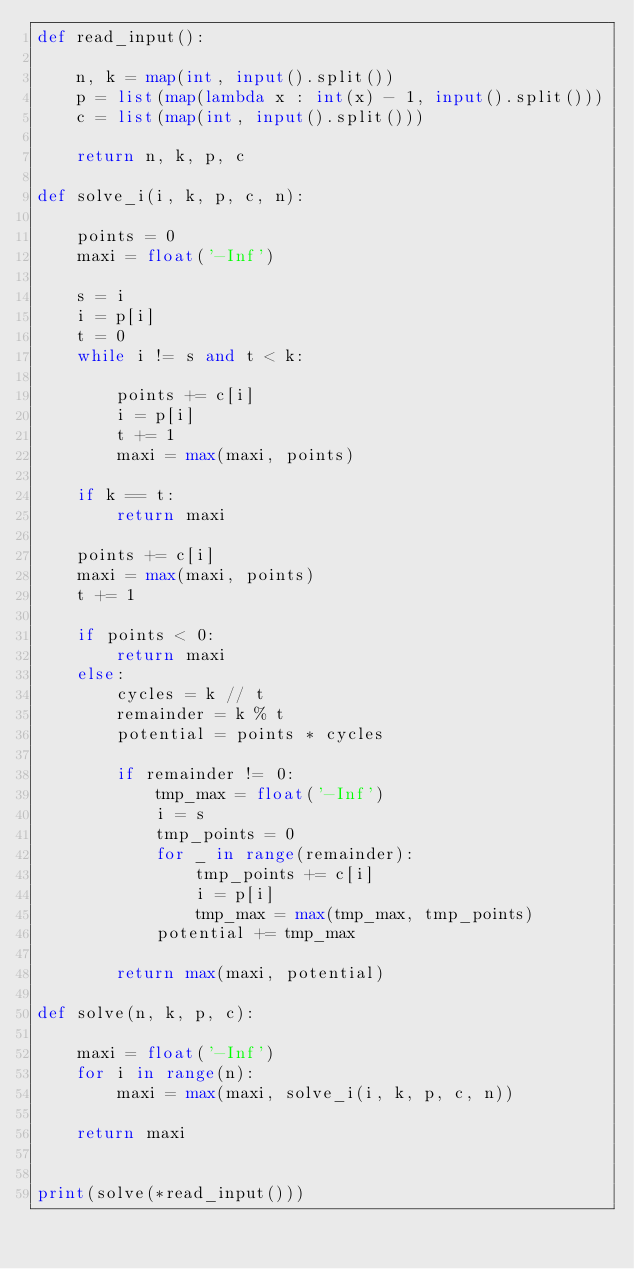<code> <loc_0><loc_0><loc_500><loc_500><_Python_>def read_input():

    n, k = map(int, input().split())
    p = list(map(lambda x : int(x) - 1, input().split()))
    c = list(map(int, input().split()))

    return n, k, p, c

def solve_i(i, k, p, c, n):
    
    points = 0
    maxi = float('-Inf')

    s = i
    i = p[i]
    t = 0
    while i != s and t < k:
        
        points += c[i]
        i = p[i]
        t += 1
        maxi = max(maxi, points)

    if k == t:
        return maxi

    points += c[i]
    maxi = max(maxi, points)
    t += 1

    if points < 0:
        return maxi
    else:
        cycles = k // t
        remainder = k % t
        potential = points * cycles

        if remainder != 0:
            tmp_max = float('-Inf')
            i = s
            tmp_points = 0
            for _ in range(remainder):
                tmp_points += c[i]
                i = p[i]
                tmp_max = max(tmp_max, tmp_points)
            potential += tmp_max

        return max(maxi, potential)

def solve(n, k, p, c):

    maxi = float('-Inf')
    for i in range(n):
        maxi = max(maxi, solve_i(i, k, p, c, n))

    return maxi


print(solve(*read_input()))
</code> 